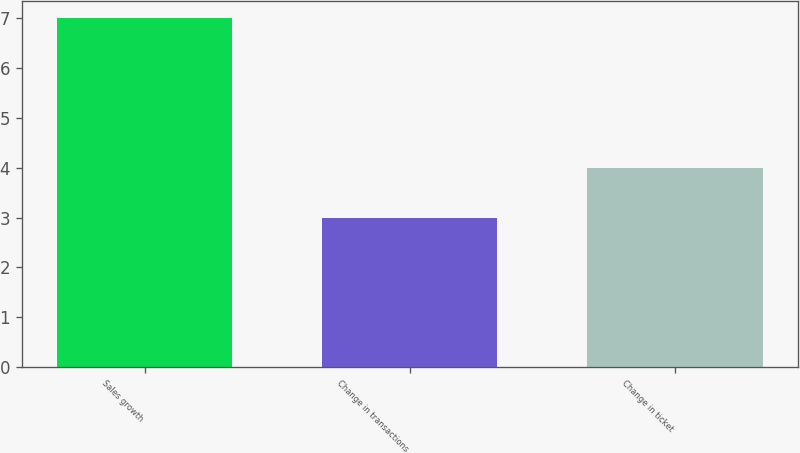<chart> <loc_0><loc_0><loc_500><loc_500><bar_chart><fcel>Sales growth<fcel>Change in transactions<fcel>Change in ticket<nl><fcel>7<fcel>3<fcel>4<nl></chart> 